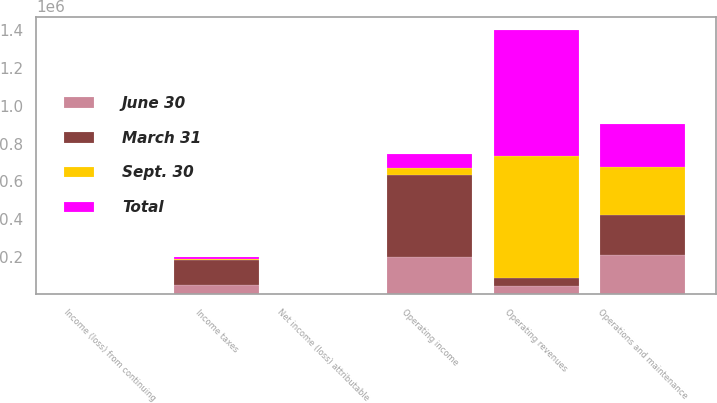Convert chart to OTSL. <chart><loc_0><loc_0><loc_500><loc_500><stacked_bar_chart><ecel><fcel>Operating revenues<fcel>Operations and maintenance<fcel>Operating income<fcel>Income taxes<fcel>Income (loss) from continuing<fcel>Net income (loss) attributable<nl><fcel>Sept. 30<fcel>648847<fcel>255029<fcel>35784<fcel>6005<fcel>0.15<fcel>0.14<nl><fcel>June 30<fcel>43301<fcel>210590<fcel>196992<fcel>50818<fcel>0.79<fcel>0.8<nl><fcel>March 31<fcel>43301<fcel>210035<fcel>435017<fcel>131416<fcel>2.25<fcel>2.34<nl><fcel>Total<fcel>667892<fcel>228632<fcel>78715<fcel>7375<fcel>0.11<fcel>0.12<nl></chart> 